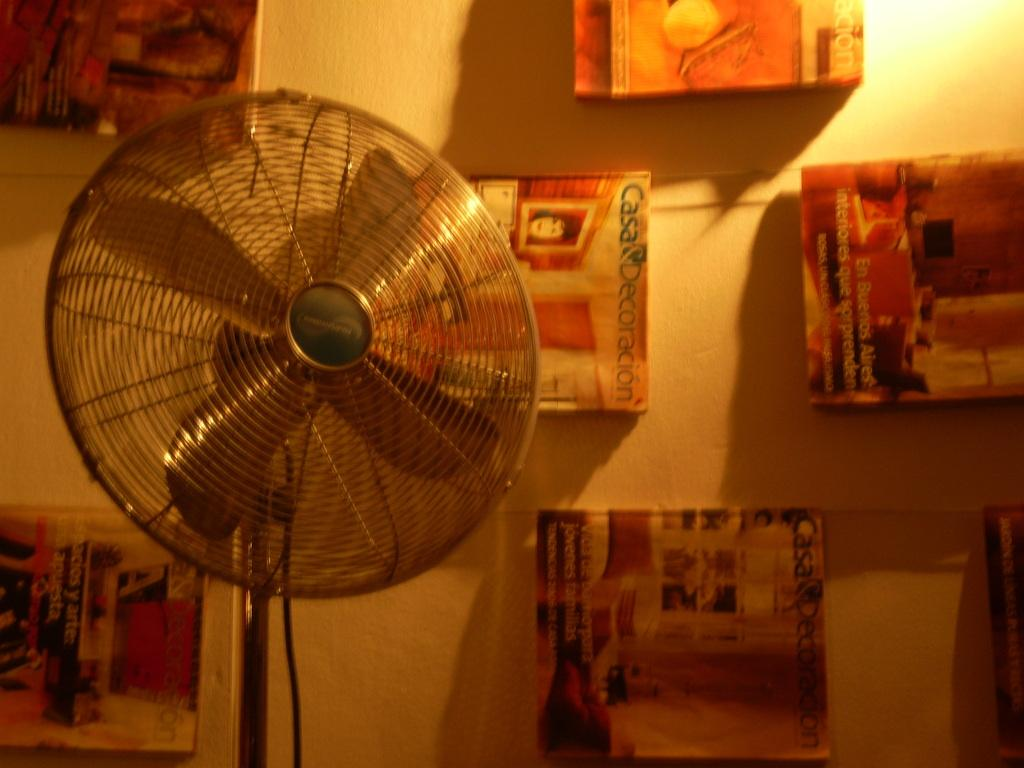<image>
Relay a brief, clear account of the picture shown. a wall with casa decorations magazines is shown 